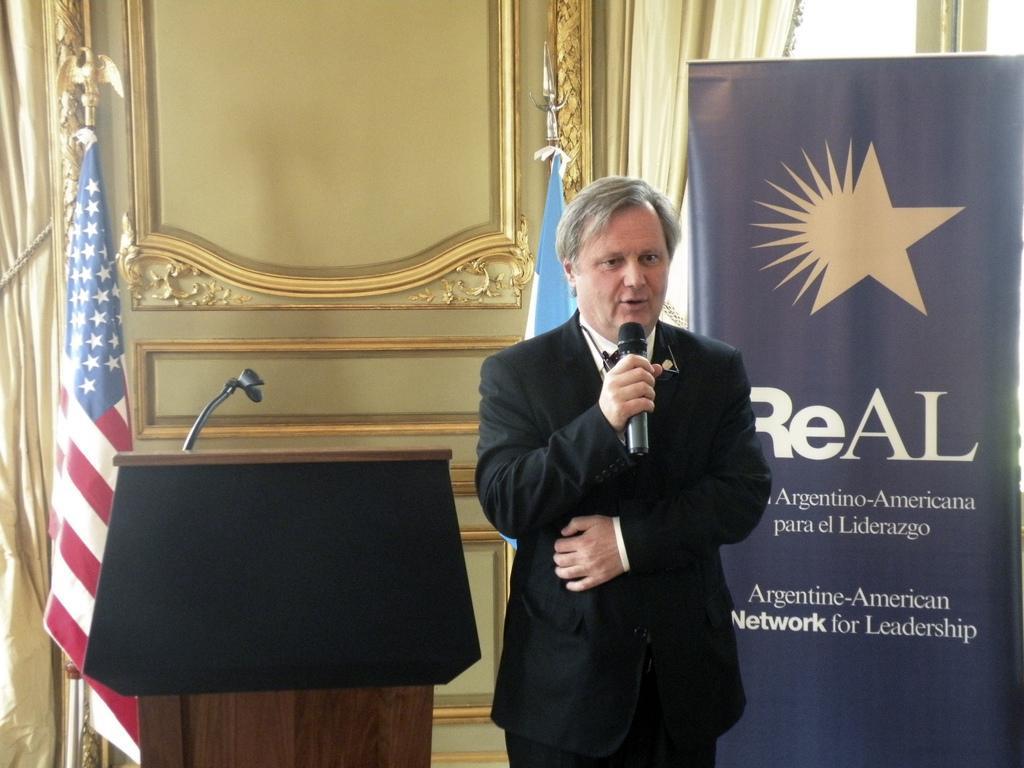How would you summarize this image in a sentence or two? There is a man standing and holding a microphone, behind him we can see banner, stand above the podium, flags and curtains. 